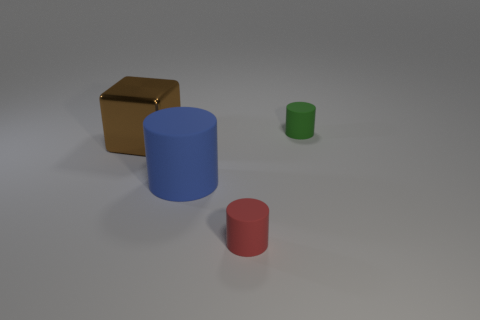The big rubber object is what color?
Your response must be concise. Blue. Is there any other thing of the same color as the big rubber cylinder?
Make the answer very short. No. What color is the other big thing that is the same shape as the red thing?
Offer a terse response. Blue. There is a rubber thing that is both behind the small red cylinder and in front of the small green cylinder; how big is it?
Provide a short and direct response. Large. There is a tiny thing right of the red matte cylinder; is its shape the same as the tiny object on the left side of the tiny green rubber cylinder?
Offer a terse response. Yes. What number of other big brown cubes have the same material as the brown block?
Your answer should be compact. 0. The thing that is to the right of the brown cube and to the left of the red matte object has what shape?
Provide a short and direct response. Cylinder. Does the red cylinder that is in front of the green thing have the same material as the green cylinder?
Your answer should be compact. Yes. Is there anything else that is the same material as the large cylinder?
Provide a short and direct response. Yes. What is the color of the other cylinder that is the same size as the green matte cylinder?
Make the answer very short. Red. 